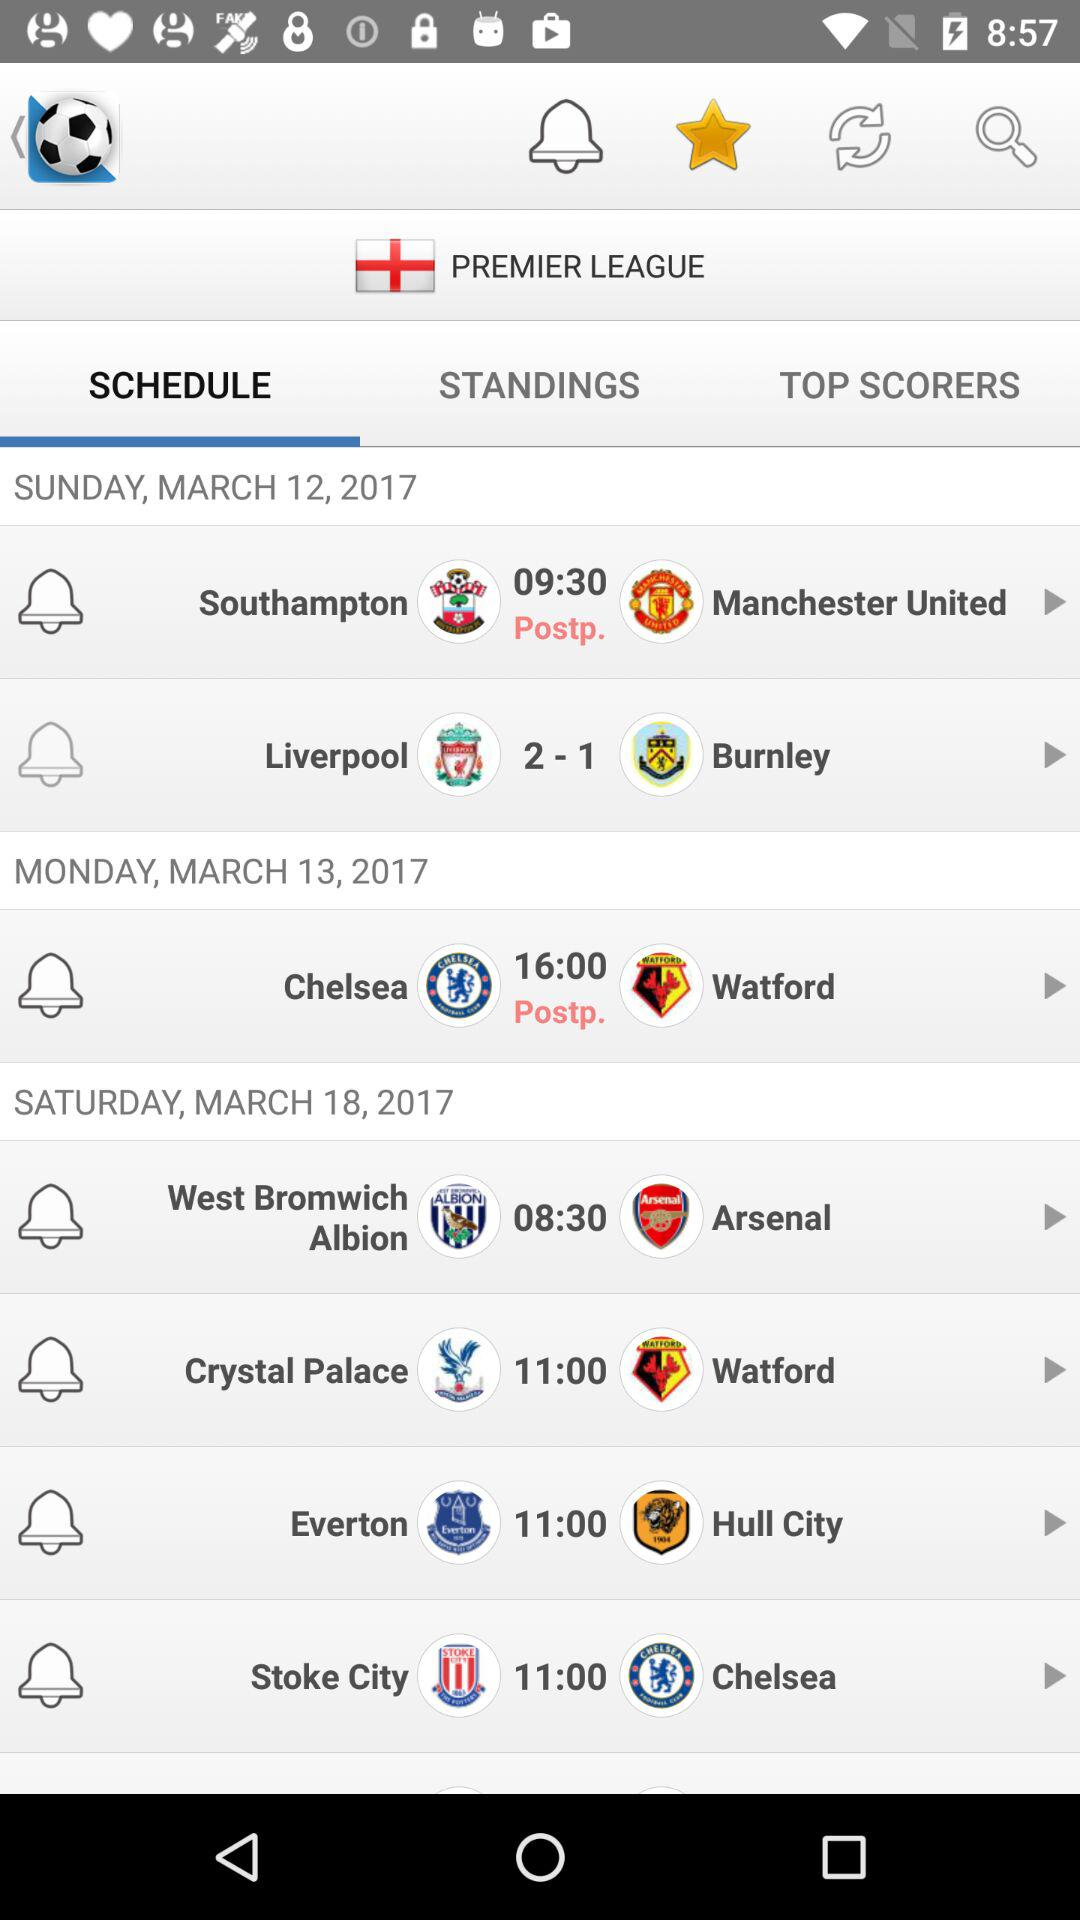What is the date on Sunday? The date is March 12, 2017. 